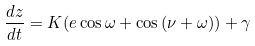Convert formula to latex. <formula><loc_0><loc_0><loc_500><loc_500>\frac { d z } { d t } = K ( e \cos { \omega } + \cos { ( \nu + \omega } ) ) + \gamma</formula> 